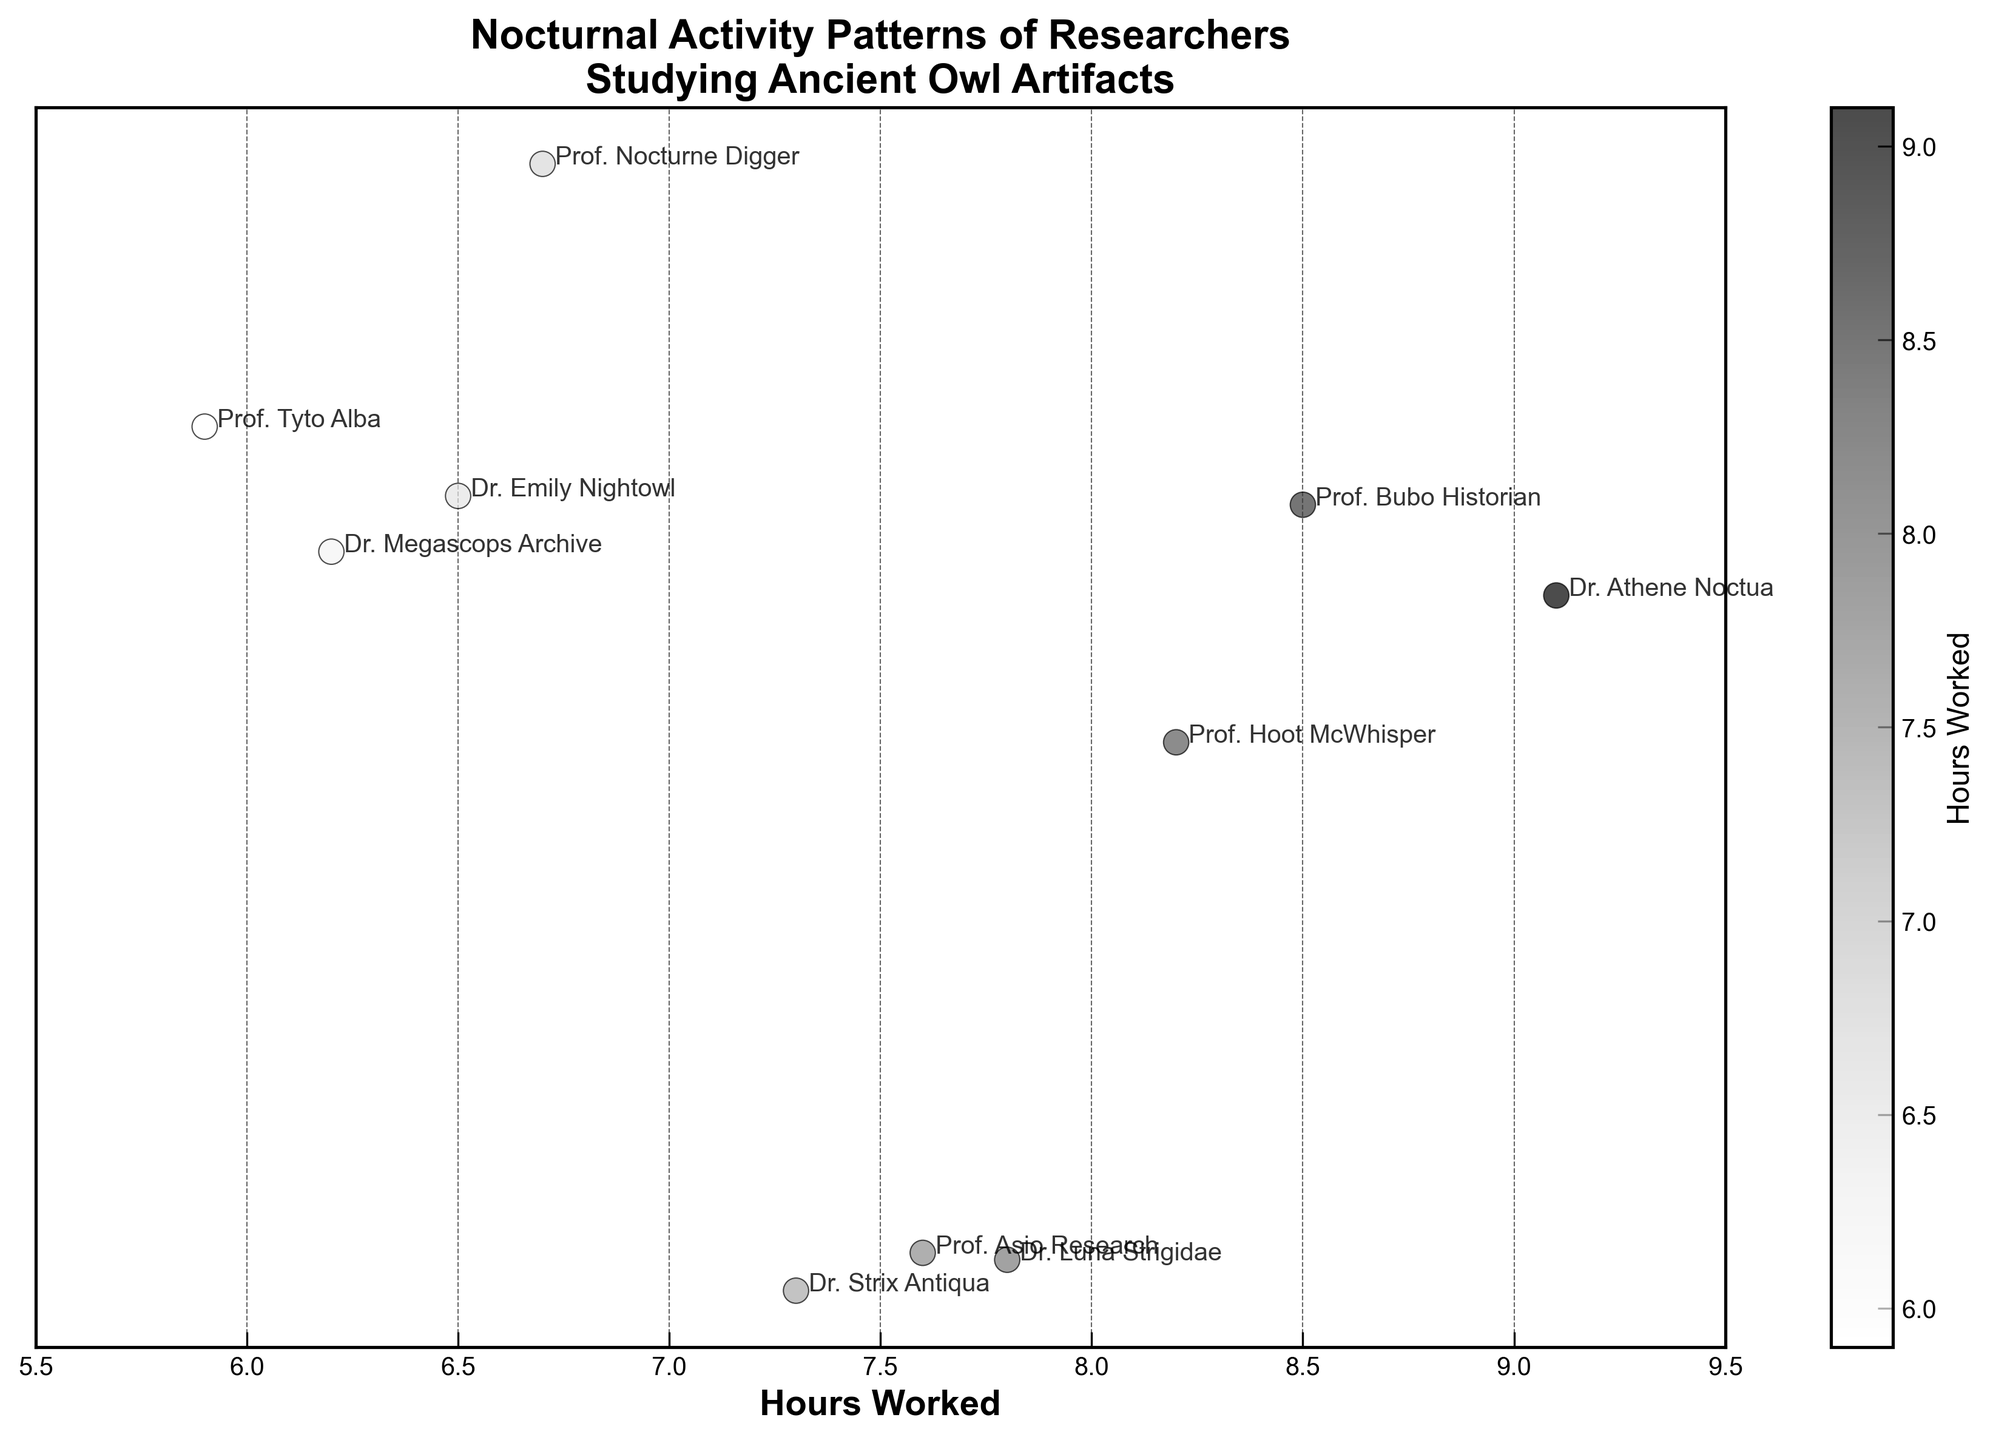What's the title of the plot? The title of the plot is prominently displayed at the top.
Answer: Nocturnal Activity Patterns of Researchers Studying Ancient Owl Artifacts How many researchers are represented in the plot? The researchers' names are annotated next to each data point. By counting these, we find the number.
Answer: 10 What is the color scale representing in the plot? The color scale is shown through a color bar on the right-hand side, indicating 'Hours Worked'.
Answer: Hours Worked Which researcher worked the most hours? Look for the highest value on the x-axis representing 'Hours Worked' and check the annotation beside it.
Answer: Dr. Athene Noctua Identify the artifact that was studied by the researcher who worked the least hours. Find the lowest 'Hours Worked' value and check the legend for the associated artifact type.
Answer: Roman Owl-Shaped Oil Lamp What's the range of hours worked among all researchers? Determine the minimum and maximum values on the x-axis and calculate their difference.
Answer: 5.9 - 9.1 Compare the hours worked by Prof. Hoot McWhisper and Prof. Tyto Alba. Who worked more? Look for the hours worked values next to these researchers' names and compare them.
Answer: Prof. Hoot McWhisper What is the average number of hours worked by the researchers? Sum up all 'Hours Worked' values and divide by the number of researchers (10).
Answer: 7.58 Among the researchers who studied artifacts from different ancient civilizations, who worked close to the average number of hours? Calculate the distance of each 'Hours Worked' value from the average (7.58) and check the closest one.
Answer: Dr. Strix Antiqua How is the data visually distributed along the x-axis? Observe the spread and clustering of the data points on the x-axis. Are they closely packed, evenly spaced, or spread out?
Answer: Spread out between 5.9 and 9.1 